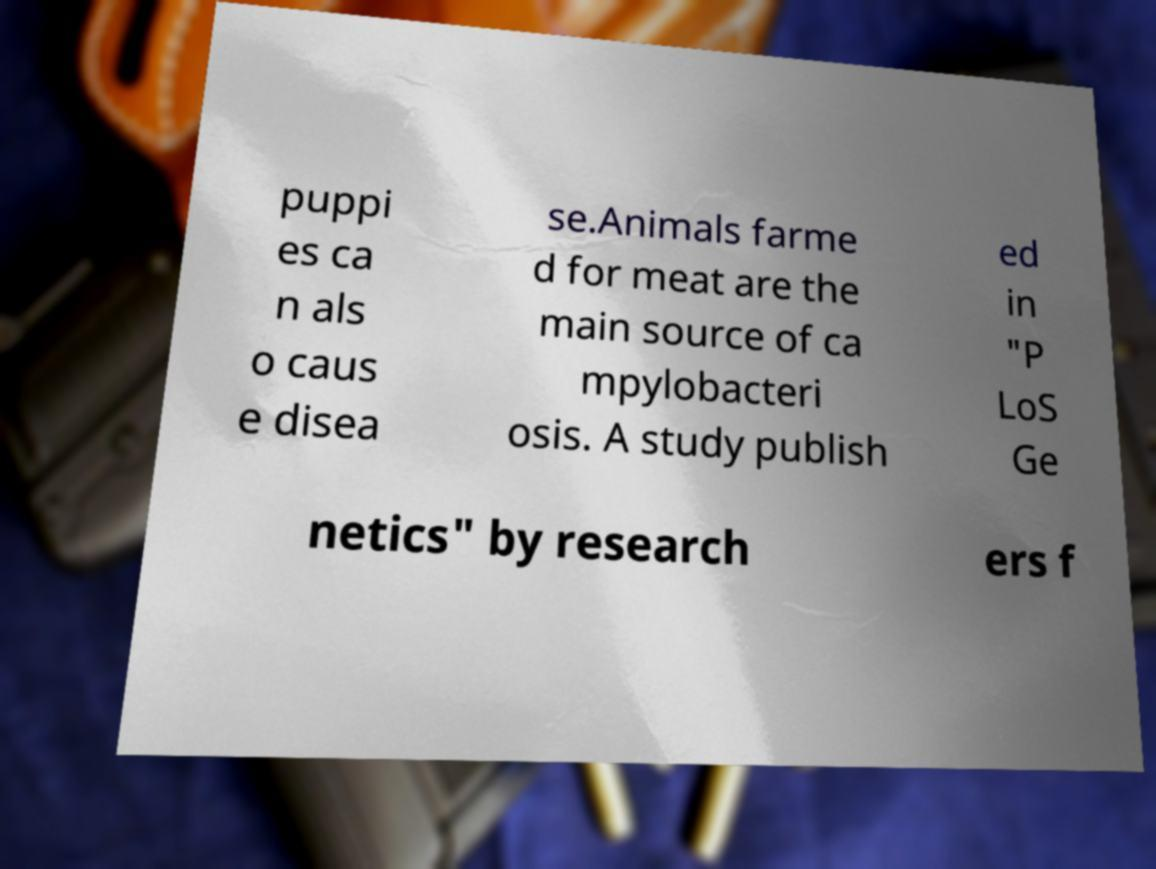What messages or text are displayed in this image? I need them in a readable, typed format. puppi es ca n als o caus e disea se.Animals farme d for meat are the main source of ca mpylobacteri osis. A study publish ed in "P LoS Ge netics" by research ers f 